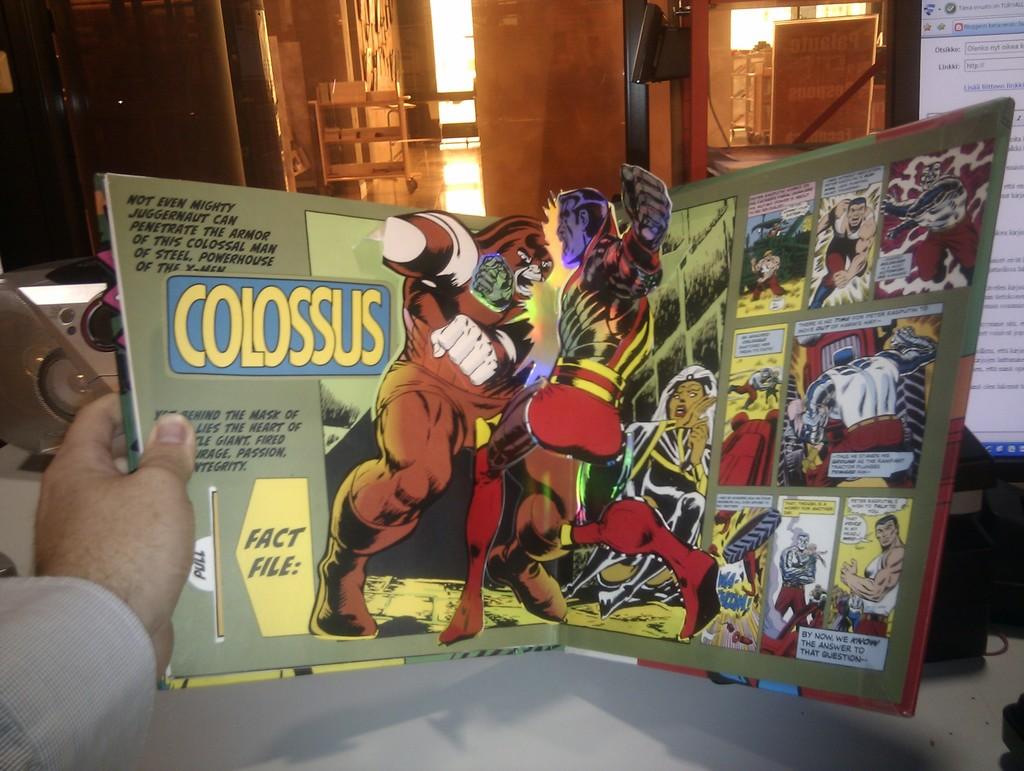Who is the comic about?
Make the answer very short. Colossus. How can you access the fact file?
Your response must be concise. Pull. 